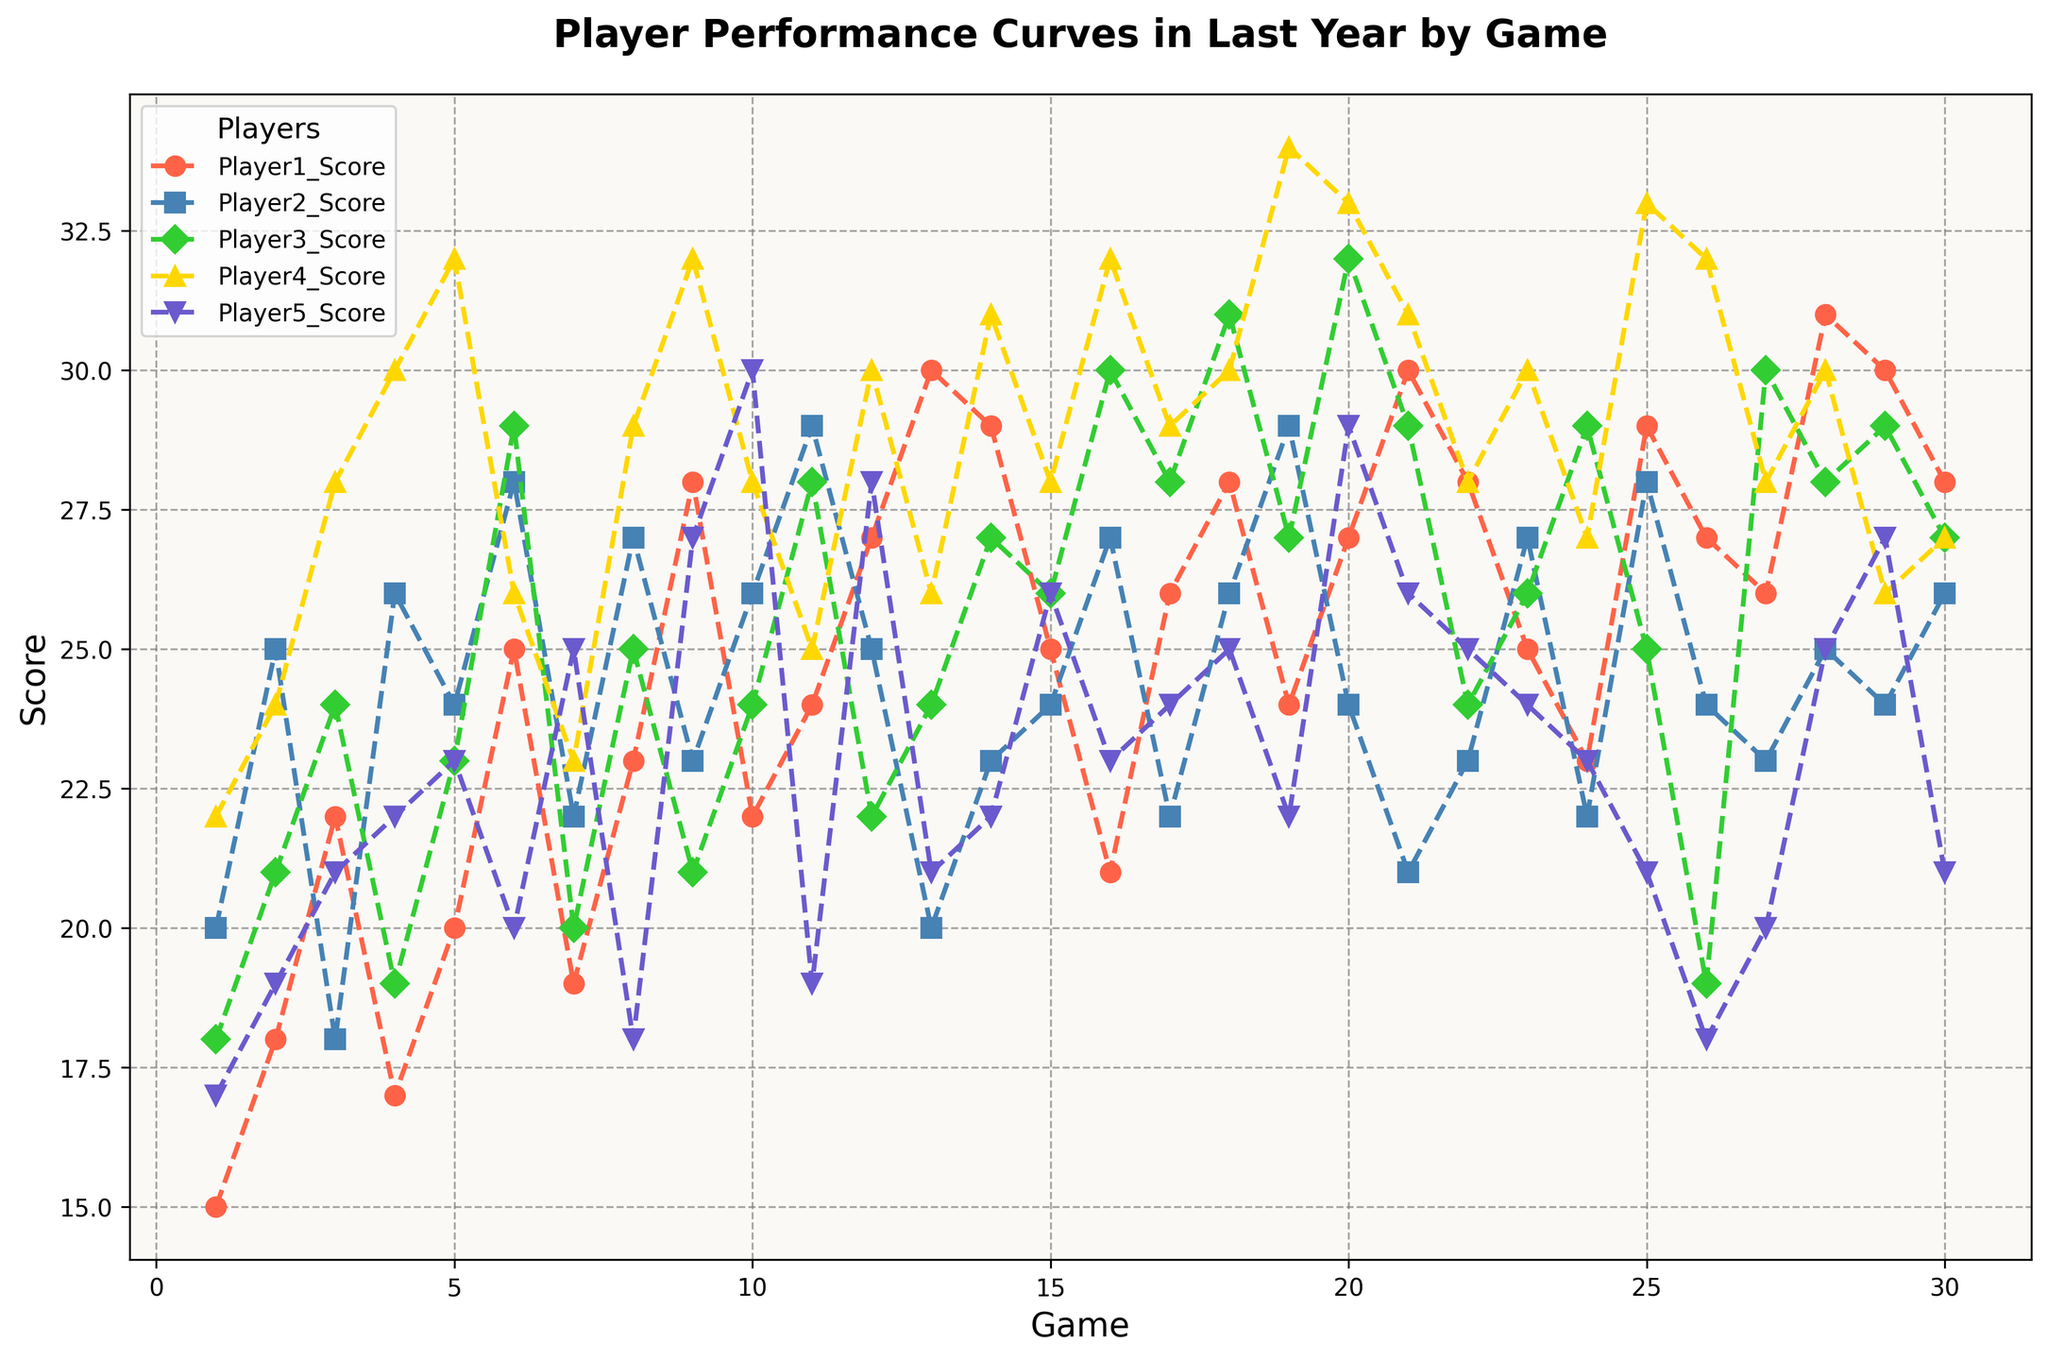Which player scored the highest in any single game? To find the player with the highest score in any single game, observe the peaks of the curves. Player 4 achieves a score of 34 in Game 19.
Answer: Player 4 Who had the most consistent performance across the games, based on the smoothness of their curve? Consistent performance implies less fluctuation in scores. By observing the smoothness of the curves, Player 5's curve appears smoother with less fluctuation compared to others.
Answer: Player 5 During which game did Player 3 score the lowest, and what was the score? Look at the dips in Player 3's curve to identify the lowest point. The lowest score is 19, which occurs during Game 26.
Answer: Game 26; 19 What is the average score of Player 1 across all games? Calculate the average by summing all scores of Player 1 and dividing by the total number of games: (15+18+22+17+20+25+19+23+28+22+24+27+30+29+25+21+26+28+24+27+30+28+25+23+29+27+26+31+30+28) / 30 = 690 / 30
Answer: 23 Between Game 10 and Game 20, which player had the highest average score? Calculate the average score for each player between Game 10 and Game 20:
- Player 1: (22+24+27+30+29+25+21+26+28+24+27) / 11 = 283 / 11 ≈ 25.73
- Player 2: (26+29+25+22+23+24+27+22+26+29+24) / 11 = 277 / 11 ≈ 25.18
- Player 3: (24+28+22+24+26+30+28+31+27+29+32) / 11 = 301 / 11 ≈ 27.36
- Player 4: (28+30+30+26+31+28+25+30+34+33+31) / 11 = 326 / 11 ≈ 29.64
- Player 5: (30+19+28+21+22+26+23+24+22+29+26) / 11 = 270 / 11 ≈ 24.55
Player 4 has the highest average score.
Answer: Player 4 Which player improved their performance the most from Game 1 to Game 30? Improvement can be evaluated by comparing the score at Game 1 with the score at Game 30 for each player:
- Player 1: 28 - 15 = 13
- Player 2: 26 - 20 = 6
- Player 3: 27 - 18 = 9
- Player 4: 27 - 22 = 5
- Player 5: 21 - 17 = 4
Player 1 shows the most improvement with an increase of 13 points.
Answer: Player 1 How many games did Player 2 outperform Player 3? Compare the scores of Player 2 and Player 3 for each game and count how many times Player 2's score is higher:
- Player 2 outperforms Player 3 in Game 1, 2, 4, 5, 7, 8, 10, 11, 12, 13, 14, 16, 17, 19, 23, 24, 25, 26, 29, and 30 (20 times in total).
Answer: 20 Which game had the highest total combined score of all players? To find the highest combined score, sum up the scores for each game and identify the maximum:
- Game 19: 24+29+27+34+22 = 136 (has the highest combined score).
Answer: Game 19 At which game did Player 5 reach their peak score, and what was the peak? Identify the peak of Player 5's curve by locating the highest point. The highest score for Player 5 is 30 in Game 10.
Answer: Game 10; 30 